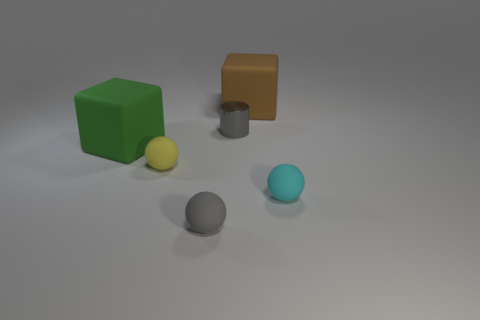Are there any other objects of the same shape as the big brown matte object?
Offer a terse response. Yes. Are there fewer green rubber blocks than rubber blocks?
Give a very brief answer. Yes. There is a matte block left of the gray metallic cylinder; is its size the same as the gray thing that is behind the big green cube?
Your answer should be very brief. No. How many things are cyan rubber blocks or large objects?
Your answer should be compact. 2. There is a gray thing that is in front of the small gray metallic cylinder; what is its size?
Provide a succinct answer. Small. What number of gray objects are behind the large block that is to the right of the rubber block in front of the tiny gray shiny cylinder?
Offer a terse response. 0. What number of tiny rubber objects are both on the right side of the tiny yellow matte ball and to the left of the cyan matte thing?
Provide a short and direct response. 1. The big thing that is on the left side of the brown rubber thing has what shape?
Your answer should be very brief. Cube. Are there fewer yellow objects that are right of the shiny object than rubber things on the left side of the cyan sphere?
Your response must be concise. Yes. Do the gray thing that is in front of the small shiny object and the tiny object that is to the right of the metal thing have the same material?
Keep it short and to the point. Yes. 